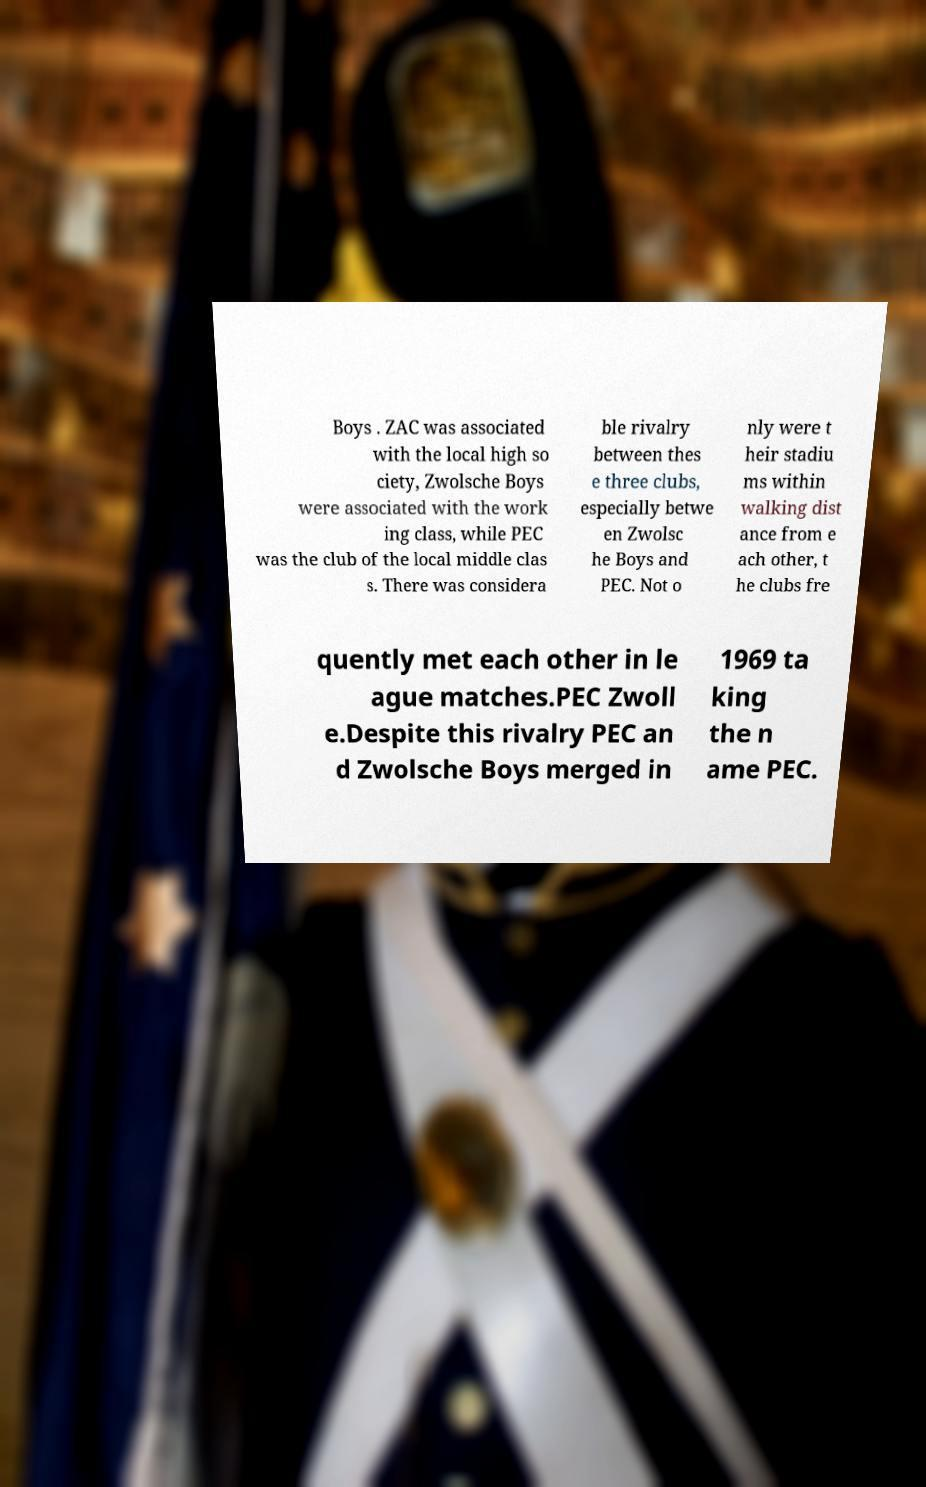Please identify and transcribe the text found in this image. Boys . ZAC was associated with the local high so ciety, Zwolsche Boys were associated with the work ing class, while PEC was the club of the local middle clas s. There was considera ble rivalry between thes e three clubs, especially betwe en Zwolsc he Boys and PEC. Not o nly were t heir stadiu ms within walking dist ance from e ach other, t he clubs fre quently met each other in le ague matches.PEC Zwoll e.Despite this rivalry PEC an d Zwolsche Boys merged in 1969 ta king the n ame PEC. 